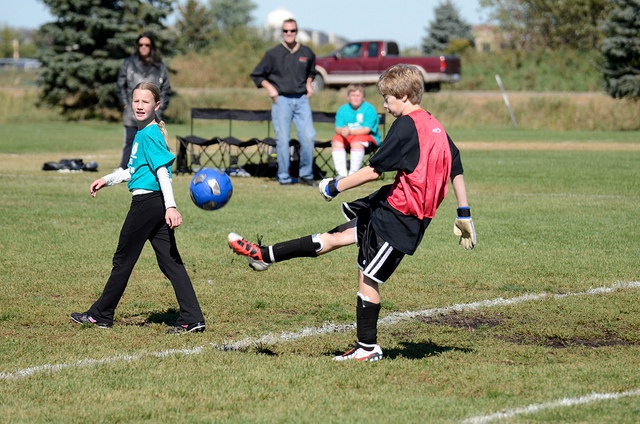Describe the objects in this image and their specific colors. I can see people in lightblue, black, lightpink, lightgray, and gray tones, people in lightblue, black, cyan, white, and olive tones, people in lightblue, black, darkgray, and gray tones, truck in lightblue, gray, brown, and black tones, and people in lightblue, lavender, cyan, lightpink, and salmon tones in this image. 